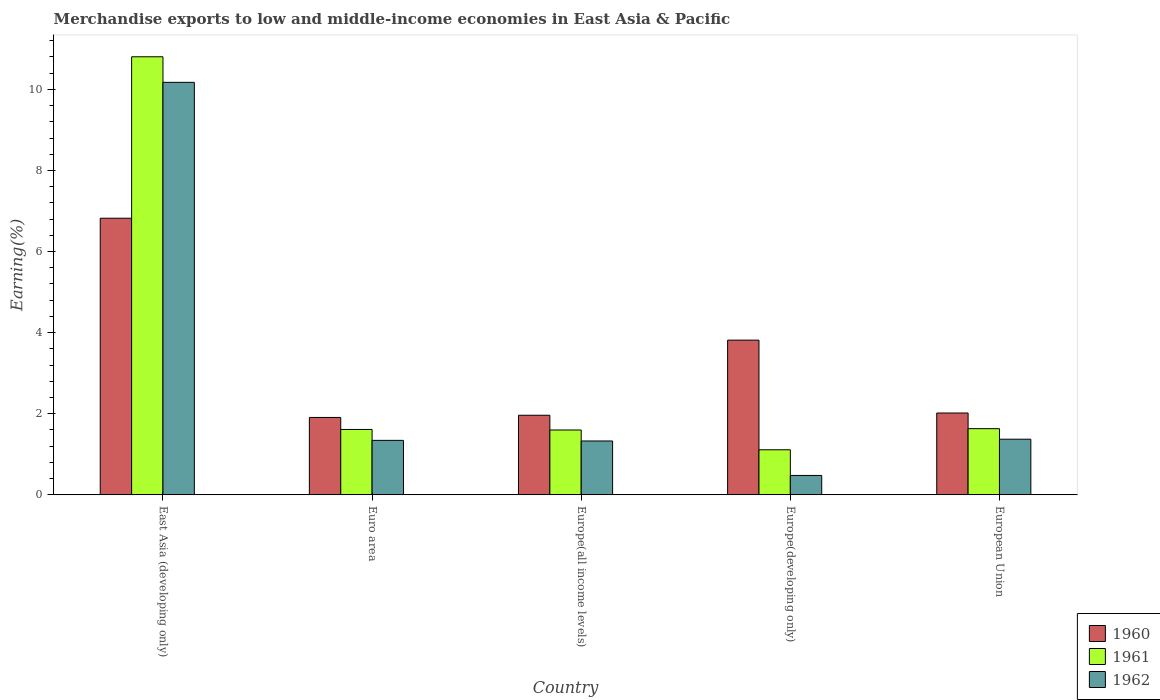How many different coloured bars are there?
Make the answer very short. 3. How many groups of bars are there?
Offer a very short reply. 5. How many bars are there on the 3rd tick from the left?
Ensure brevity in your answer.  3. What is the label of the 1st group of bars from the left?
Your answer should be compact. East Asia (developing only). What is the percentage of amount earned from merchandise exports in 1961 in European Union?
Provide a short and direct response. 1.63. Across all countries, what is the maximum percentage of amount earned from merchandise exports in 1961?
Your response must be concise. 10.8. Across all countries, what is the minimum percentage of amount earned from merchandise exports in 1962?
Ensure brevity in your answer.  0.48. In which country was the percentage of amount earned from merchandise exports in 1960 maximum?
Your answer should be very brief. East Asia (developing only). In which country was the percentage of amount earned from merchandise exports in 1961 minimum?
Offer a terse response. Europe(developing only). What is the total percentage of amount earned from merchandise exports in 1961 in the graph?
Make the answer very short. 16.76. What is the difference between the percentage of amount earned from merchandise exports in 1961 in Europe(all income levels) and that in European Union?
Make the answer very short. -0.03. What is the difference between the percentage of amount earned from merchandise exports in 1961 in Euro area and the percentage of amount earned from merchandise exports in 1960 in Europe(all income levels)?
Provide a short and direct response. -0.35. What is the average percentage of amount earned from merchandise exports in 1961 per country?
Ensure brevity in your answer.  3.35. What is the difference between the percentage of amount earned from merchandise exports of/in 1961 and percentage of amount earned from merchandise exports of/in 1962 in Europe(developing only)?
Make the answer very short. 0.63. In how many countries, is the percentage of amount earned from merchandise exports in 1960 greater than 0.4 %?
Offer a very short reply. 5. What is the ratio of the percentage of amount earned from merchandise exports in 1962 in Europe(all income levels) to that in European Union?
Offer a terse response. 0.97. Is the difference between the percentage of amount earned from merchandise exports in 1961 in Europe(all income levels) and European Union greater than the difference between the percentage of amount earned from merchandise exports in 1962 in Europe(all income levels) and European Union?
Keep it short and to the point. Yes. What is the difference between the highest and the second highest percentage of amount earned from merchandise exports in 1960?
Your answer should be compact. -1.8. What is the difference between the highest and the lowest percentage of amount earned from merchandise exports in 1960?
Offer a very short reply. 4.91. In how many countries, is the percentage of amount earned from merchandise exports in 1961 greater than the average percentage of amount earned from merchandise exports in 1961 taken over all countries?
Keep it short and to the point. 1. What does the 2nd bar from the left in European Union represents?
Offer a very short reply. 1961. How many bars are there?
Your answer should be compact. 15. How many countries are there in the graph?
Keep it short and to the point. 5. Are the values on the major ticks of Y-axis written in scientific E-notation?
Keep it short and to the point. No. Does the graph contain any zero values?
Your answer should be very brief. No. How are the legend labels stacked?
Provide a succinct answer. Vertical. What is the title of the graph?
Provide a short and direct response. Merchandise exports to low and middle-income economies in East Asia & Pacific. What is the label or title of the X-axis?
Your response must be concise. Country. What is the label or title of the Y-axis?
Give a very brief answer. Earning(%). What is the Earning(%) in 1960 in East Asia (developing only)?
Provide a succinct answer. 6.82. What is the Earning(%) in 1961 in East Asia (developing only)?
Give a very brief answer. 10.8. What is the Earning(%) of 1962 in East Asia (developing only)?
Provide a short and direct response. 10.17. What is the Earning(%) of 1960 in Euro area?
Ensure brevity in your answer.  1.91. What is the Earning(%) of 1961 in Euro area?
Your answer should be very brief. 1.61. What is the Earning(%) in 1962 in Euro area?
Offer a very short reply. 1.34. What is the Earning(%) of 1960 in Europe(all income levels)?
Provide a short and direct response. 1.96. What is the Earning(%) in 1961 in Europe(all income levels)?
Ensure brevity in your answer.  1.6. What is the Earning(%) in 1962 in Europe(all income levels)?
Offer a very short reply. 1.33. What is the Earning(%) of 1960 in Europe(developing only)?
Your answer should be very brief. 3.82. What is the Earning(%) in 1961 in Europe(developing only)?
Your response must be concise. 1.11. What is the Earning(%) in 1962 in Europe(developing only)?
Ensure brevity in your answer.  0.48. What is the Earning(%) in 1960 in European Union?
Offer a terse response. 2.02. What is the Earning(%) of 1961 in European Union?
Your response must be concise. 1.63. What is the Earning(%) of 1962 in European Union?
Provide a short and direct response. 1.37. Across all countries, what is the maximum Earning(%) in 1960?
Provide a succinct answer. 6.82. Across all countries, what is the maximum Earning(%) in 1961?
Provide a succinct answer. 10.8. Across all countries, what is the maximum Earning(%) of 1962?
Your answer should be compact. 10.17. Across all countries, what is the minimum Earning(%) in 1960?
Ensure brevity in your answer.  1.91. Across all countries, what is the minimum Earning(%) in 1961?
Make the answer very short. 1.11. Across all countries, what is the minimum Earning(%) of 1962?
Provide a succinct answer. 0.48. What is the total Earning(%) of 1960 in the graph?
Provide a short and direct response. 16.52. What is the total Earning(%) of 1961 in the graph?
Provide a succinct answer. 16.76. What is the total Earning(%) of 1962 in the graph?
Provide a succinct answer. 14.69. What is the difference between the Earning(%) of 1960 in East Asia (developing only) and that in Euro area?
Ensure brevity in your answer.  4.91. What is the difference between the Earning(%) in 1961 in East Asia (developing only) and that in Euro area?
Your answer should be compact. 9.19. What is the difference between the Earning(%) in 1962 in East Asia (developing only) and that in Euro area?
Your answer should be very brief. 8.83. What is the difference between the Earning(%) of 1960 in East Asia (developing only) and that in Europe(all income levels)?
Offer a very short reply. 4.86. What is the difference between the Earning(%) of 1961 in East Asia (developing only) and that in Europe(all income levels)?
Your response must be concise. 9.21. What is the difference between the Earning(%) in 1962 in East Asia (developing only) and that in Europe(all income levels)?
Your response must be concise. 8.85. What is the difference between the Earning(%) in 1960 in East Asia (developing only) and that in Europe(developing only)?
Your answer should be very brief. 3.01. What is the difference between the Earning(%) in 1961 in East Asia (developing only) and that in Europe(developing only)?
Provide a succinct answer. 9.69. What is the difference between the Earning(%) of 1962 in East Asia (developing only) and that in Europe(developing only)?
Your answer should be very brief. 9.7. What is the difference between the Earning(%) in 1960 in East Asia (developing only) and that in European Union?
Give a very brief answer. 4.8. What is the difference between the Earning(%) in 1961 in East Asia (developing only) and that in European Union?
Provide a short and direct response. 9.17. What is the difference between the Earning(%) in 1962 in East Asia (developing only) and that in European Union?
Provide a short and direct response. 8.8. What is the difference between the Earning(%) of 1960 in Euro area and that in Europe(all income levels)?
Your response must be concise. -0.05. What is the difference between the Earning(%) in 1961 in Euro area and that in Europe(all income levels)?
Offer a very short reply. 0.01. What is the difference between the Earning(%) in 1962 in Euro area and that in Europe(all income levels)?
Your answer should be very brief. 0.01. What is the difference between the Earning(%) in 1960 in Euro area and that in Europe(developing only)?
Provide a short and direct response. -1.91. What is the difference between the Earning(%) in 1961 in Euro area and that in Europe(developing only)?
Keep it short and to the point. 0.5. What is the difference between the Earning(%) of 1962 in Euro area and that in Europe(developing only)?
Offer a terse response. 0.87. What is the difference between the Earning(%) of 1960 in Euro area and that in European Union?
Your answer should be compact. -0.11. What is the difference between the Earning(%) in 1961 in Euro area and that in European Union?
Ensure brevity in your answer.  -0.02. What is the difference between the Earning(%) of 1962 in Euro area and that in European Union?
Give a very brief answer. -0.03. What is the difference between the Earning(%) in 1960 in Europe(all income levels) and that in Europe(developing only)?
Give a very brief answer. -1.85. What is the difference between the Earning(%) of 1961 in Europe(all income levels) and that in Europe(developing only)?
Give a very brief answer. 0.49. What is the difference between the Earning(%) of 1962 in Europe(all income levels) and that in Europe(developing only)?
Provide a succinct answer. 0.85. What is the difference between the Earning(%) in 1960 in Europe(all income levels) and that in European Union?
Give a very brief answer. -0.06. What is the difference between the Earning(%) in 1961 in Europe(all income levels) and that in European Union?
Your response must be concise. -0.03. What is the difference between the Earning(%) in 1962 in Europe(all income levels) and that in European Union?
Keep it short and to the point. -0.04. What is the difference between the Earning(%) in 1960 in Europe(developing only) and that in European Union?
Provide a succinct answer. 1.8. What is the difference between the Earning(%) of 1961 in Europe(developing only) and that in European Union?
Make the answer very short. -0.52. What is the difference between the Earning(%) of 1962 in Europe(developing only) and that in European Union?
Ensure brevity in your answer.  -0.89. What is the difference between the Earning(%) of 1960 in East Asia (developing only) and the Earning(%) of 1961 in Euro area?
Your answer should be very brief. 5.21. What is the difference between the Earning(%) of 1960 in East Asia (developing only) and the Earning(%) of 1962 in Euro area?
Offer a very short reply. 5.48. What is the difference between the Earning(%) of 1961 in East Asia (developing only) and the Earning(%) of 1962 in Euro area?
Provide a short and direct response. 9.46. What is the difference between the Earning(%) in 1960 in East Asia (developing only) and the Earning(%) in 1961 in Europe(all income levels)?
Offer a very short reply. 5.22. What is the difference between the Earning(%) of 1960 in East Asia (developing only) and the Earning(%) of 1962 in Europe(all income levels)?
Your answer should be very brief. 5.49. What is the difference between the Earning(%) in 1961 in East Asia (developing only) and the Earning(%) in 1962 in Europe(all income levels)?
Make the answer very short. 9.48. What is the difference between the Earning(%) of 1960 in East Asia (developing only) and the Earning(%) of 1961 in Europe(developing only)?
Offer a very short reply. 5.71. What is the difference between the Earning(%) in 1960 in East Asia (developing only) and the Earning(%) in 1962 in Europe(developing only)?
Provide a short and direct response. 6.34. What is the difference between the Earning(%) of 1961 in East Asia (developing only) and the Earning(%) of 1962 in Europe(developing only)?
Make the answer very short. 10.33. What is the difference between the Earning(%) of 1960 in East Asia (developing only) and the Earning(%) of 1961 in European Union?
Make the answer very short. 5.19. What is the difference between the Earning(%) of 1960 in East Asia (developing only) and the Earning(%) of 1962 in European Union?
Ensure brevity in your answer.  5.45. What is the difference between the Earning(%) in 1961 in East Asia (developing only) and the Earning(%) in 1962 in European Union?
Your response must be concise. 9.43. What is the difference between the Earning(%) of 1960 in Euro area and the Earning(%) of 1961 in Europe(all income levels)?
Provide a succinct answer. 0.31. What is the difference between the Earning(%) in 1960 in Euro area and the Earning(%) in 1962 in Europe(all income levels)?
Make the answer very short. 0.58. What is the difference between the Earning(%) in 1961 in Euro area and the Earning(%) in 1962 in Europe(all income levels)?
Provide a succinct answer. 0.28. What is the difference between the Earning(%) in 1960 in Euro area and the Earning(%) in 1961 in Europe(developing only)?
Ensure brevity in your answer.  0.8. What is the difference between the Earning(%) of 1960 in Euro area and the Earning(%) of 1962 in Europe(developing only)?
Make the answer very short. 1.43. What is the difference between the Earning(%) in 1961 in Euro area and the Earning(%) in 1962 in Europe(developing only)?
Keep it short and to the point. 1.13. What is the difference between the Earning(%) of 1960 in Euro area and the Earning(%) of 1961 in European Union?
Offer a very short reply. 0.28. What is the difference between the Earning(%) of 1960 in Euro area and the Earning(%) of 1962 in European Union?
Offer a terse response. 0.54. What is the difference between the Earning(%) in 1961 in Euro area and the Earning(%) in 1962 in European Union?
Offer a very short reply. 0.24. What is the difference between the Earning(%) in 1960 in Europe(all income levels) and the Earning(%) in 1961 in Europe(developing only)?
Your answer should be compact. 0.85. What is the difference between the Earning(%) of 1960 in Europe(all income levels) and the Earning(%) of 1962 in Europe(developing only)?
Your answer should be very brief. 1.48. What is the difference between the Earning(%) of 1961 in Europe(all income levels) and the Earning(%) of 1962 in Europe(developing only)?
Provide a short and direct response. 1.12. What is the difference between the Earning(%) in 1960 in Europe(all income levels) and the Earning(%) in 1961 in European Union?
Give a very brief answer. 0.33. What is the difference between the Earning(%) in 1960 in Europe(all income levels) and the Earning(%) in 1962 in European Union?
Ensure brevity in your answer.  0.59. What is the difference between the Earning(%) in 1961 in Europe(all income levels) and the Earning(%) in 1962 in European Union?
Make the answer very short. 0.23. What is the difference between the Earning(%) in 1960 in Europe(developing only) and the Earning(%) in 1961 in European Union?
Offer a very short reply. 2.18. What is the difference between the Earning(%) of 1960 in Europe(developing only) and the Earning(%) of 1962 in European Union?
Your answer should be very brief. 2.44. What is the difference between the Earning(%) in 1961 in Europe(developing only) and the Earning(%) in 1962 in European Union?
Your answer should be compact. -0.26. What is the average Earning(%) of 1960 per country?
Your response must be concise. 3.3. What is the average Earning(%) of 1961 per country?
Offer a very short reply. 3.35. What is the average Earning(%) in 1962 per country?
Make the answer very short. 2.94. What is the difference between the Earning(%) in 1960 and Earning(%) in 1961 in East Asia (developing only)?
Give a very brief answer. -3.98. What is the difference between the Earning(%) of 1960 and Earning(%) of 1962 in East Asia (developing only)?
Make the answer very short. -3.35. What is the difference between the Earning(%) in 1961 and Earning(%) in 1962 in East Asia (developing only)?
Provide a short and direct response. 0.63. What is the difference between the Earning(%) in 1960 and Earning(%) in 1961 in Euro area?
Provide a short and direct response. 0.3. What is the difference between the Earning(%) of 1960 and Earning(%) of 1962 in Euro area?
Offer a terse response. 0.57. What is the difference between the Earning(%) of 1961 and Earning(%) of 1962 in Euro area?
Your response must be concise. 0.27. What is the difference between the Earning(%) in 1960 and Earning(%) in 1961 in Europe(all income levels)?
Your answer should be compact. 0.36. What is the difference between the Earning(%) of 1960 and Earning(%) of 1962 in Europe(all income levels)?
Offer a terse response. 0.63. What is the difference between the Earning(%) of 1961 and Earning(%) of 1962 in Europe(all income levels)?
Provide a short and direct response. 0.27. What is the difference between the Earning(%) in 1960 and Earning(%) in 1961 in Europe(developing only)?
Your response must be concise. 2.7. What is the difference between the Earning(%) of 1960 and Earning(%) of 1962 in Europe(developing only)?
Make the answer very short. 3.34. What is the difference between the Earning(%) of 1961 and Earning(%) of 1962 in Europe(developing only)?
Your answer should be very brief. 0.63. What is the difference between the Earning(%) in 1960 and Earning(%) in 1961 in European Union?
Give a very brief answer. 0.39. What is the difference between the Earning(%) of 1960 and Earning(%) of 1962 in European Union?
Provide a short and direct response. 0.65. What is the difference between the Earning(%) in 1961 and Earning(%) in 1962 in European Union?
Offer a very short reply. 0.26. What is the ratio of the Earning(%) of 1960 in East Asia (developing only) to that in Euro area?
Give a very brief answer. 3.58. What is the ratio of the Earning(%) in 1961 in East Asia (developing only) to that in Euro area?
Your answer should be very brief. 6.7. What is the ratio of the Earning(%) of 1962 in East Asia (developing only) to that in Euro area?
Give a very brief answer. 7.58. What is the ratio of the Earning(%) in 1960 in East Asia (developing only) to that in Europe(all income levels)?
Offer a terse response. 3.48. What is the ratio of the Earning(%) of 1961 in East Asia (developing only) to that in Europe(all income levels)?
Offer a very short reply. 6.76. What is the ratio of the Earning(%) in 1962 in East Asia (developing only) to that in Europe(all income levels)?
Ensure brevity in your answer.  7.66. What is the ratio of the Earning(%) of 1960 in East Asia (developing only) to that in Europe(developing only)?
Keep it short and to the point. 1.79. What is the ratio of the Earning(%) in 1961 in East Asia (developing only) to that in Europe(developing only)?
Make the answer very short. 9.73. What is the ratio of the Earning(%) in 1962 in East Asia (developing only) to that in Europe(developing only)?
Provide a succinct answer. 21.31. What is the ratio of the Earning(%) in 1960 in East Asia (developing only) to that in European Union?
Your answer should be very brief. 3.38. What is the ratio of the Earning(%) of 1961 in East Asia (developing only) to that in European Union?
Provide a short and direct response. 6.62. What is the ratio of the Earning(%) in 1962 in East Asia (developing only) to that in European Union?
Your answer should be very brief. 7.42. What is the ratio of the Earning(%) of 1960 in Euro area to that in Europe(all income levels)?
Your answer should be compact. 0.97. What is the ratio of the Earning(%) of 1961 in Euro area to that in Europe(all income levels)?
Provide a short and direct response. 1.01. What is the ratio of the Earning(%) in 1962 in Euro area to that in Europe(all income levels)?
Give a very brief answer. 1.01. What is the ratio of the Earning(%) in 1960 in Euro area to that in Europe(developing only)?
Make the answer very short. 0.5. What is the ratio of the Earning(%) in 1961 in Euro area to that in Europe(developing only)?
Keep it short and to the point. 1.45. What is the ratio of the Earning(%) of 1962 in Euro area to that in Europe(developing only)?
Ensure brevity in your answer.  2.81. What is the ratio of the Earning(%) of 1960 in Euro area to that in European Union?
Your response must be concise. 0.95. What is the ratio of the Earning(%) of 1961 in Euro area to that in European Union?
Offer a terse response. 0.99. What is the ratio of the Earning(%) in 1962 in Euro area to that in European Union?
Give a very brief answer. 0.98. What is the ratio of the Earning(%) in 1960 in Europe(all income levels) to that in Europe(developing only)?
Make the answer very short. 0.51. What is the ratio of the Earning(%) of 1961 in Europe(all income levels) to that in Europe(developing only)?
Your response must be concise. 1.44. What is the ratio of the Earning(%) of 1962 in Europe(all income levels) to that in Europe(developing only)?
Offer a terse response. 2.78. What is the ratio of the Earning(%) of 1960 in Europe(all income levels) to that in European Union?
Give a very brief answer. 0.97. What is the ratio of the Earning(%) of 1961 in Europe(all income levels) to that in European Union?
Keep it short and to the point. 0.98. What is the ratio of the Earning(%) of 1960 in Europe(developing only) to that in European Union?
Your answer should be very brief. 1.89. What is the ratio of the Earning(%) of 1961 in Europe(developing only) to that in European Union?
Your answer should be very brief. 0.68. What is the ratio of the Earning(%) in 1962 in Europe(developing only) to that in European Union?
Provide a short and direct response. 0.35. What is the difference between the highest and the second highest Earning(%) of 1960?
Make the answer very short. 3.01. What is the difference between the highest and the second highest Earning(%) of 1961?
Give a very brief answer. 9.17. What is the difference between the highest and the second highest Earning(%) of 1962?
Provide a short and direct response. 8.8. What is the difference between the highest and the lowest Earning(%) in 1960?
Make the answer very short. 4.91. What is the difference between the highest and the lowest Earning(%) in 1961?
Ensure brevity in your answer.  9.69. What is the difference between the highest and the lowest Earning(%) in 1962?
Provide a short and direct response. 9.7. 